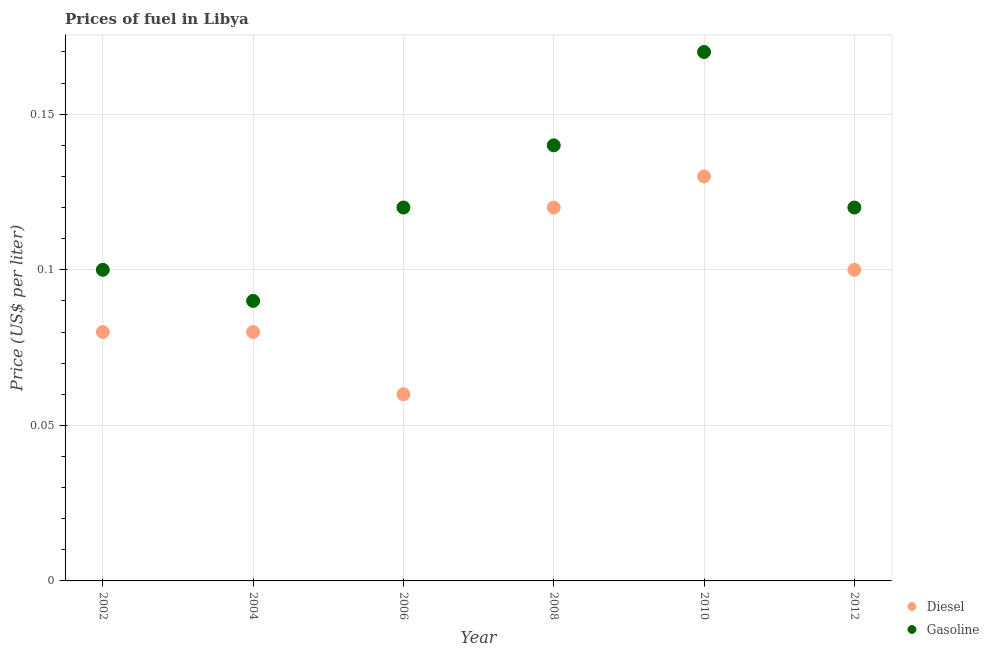Is the number of dotlines equal to the number of legend labels?
Provide a short and direct response. Yes. What is the gasoline price in 2008?
Offer a terse response. 0.14. Across all years, what is the maximum gasoline price?
Make the answer very short. 0.17. Across all years, what is the minimum gasoline price?
Offer a terse response. 0.09. What is the total gasoline price in the graph?
Provide a short and direct response. 0.74. What is the difference between the diesel price in 2008 and that in 2010?
Your answer should be compact. -0.01. What is the difference between the diesel price in 2010 and the gasoline price in 2012?
Keep it short and to the point. 0.01. What is the average gasoline price per year?
Give a very brief answer. 0.12. In the year 2004, what is the difference between the gasoline price and diesel price?
Ensure brevity in your answer.  0.01. In how many years, is the gasoline price greater than 0.12000000000000001 US$ per litre?
Ensure brevity in your answer.  2. What is the ratio of the gasoline price in 2006 to that in 2008?
Offer a very short reply. 0.86. Is the diesel price in 2008 less than that in 2012?
Offer a very short reply. No. What is the difference between the highest and the second highest diesel price?
Your response must be concise. 0.01. What is the difference between the highest and the lowest gasoline price?
Give a very brief answer. 0.08. In how many years, is the gasoline price greater than the average gasoline price taken over all years?
Give a very brief answer. 2. Does the diesel price monotonically increase over the years?
Provide a succinct answer. No. Where does the legend appear in the graph?
Your answer should be very brief. Bottom right. How many legend labels are there?
Offer a very short reply. 2. What is the title of the graph?
Give a very brief answer. Prices of fuel in Libya. What is the label or title of the X-axis?
Provide a short and direct response. Year. What is the label or title of the Y-axis?
Offer a very short reply. Price (US$ per liter). What is the Price (US$ per liter) of Diesel in 2002?
Your answer should be compact. 0.08. What is the Price (US$ per liter) of Gasoline in 2002?
Provide a short and direct response. 0.1. What is the Price (US$ per liter) in Gasoline in 2004?
Keep it short and to the point. 0.09. What is the Price (US$ per liter) of Diesel in 2006?
Your response must be concise. 0.06. What is the Price (US$ per liter) of Gasoline in 2006?
Your answer should be compact. 0.12. What is the Price (US$ per liter) of Diesel in 2008?
Offer a terse response. 0.12. What is the Price (US$ per liter) of Gasoline in 2008?
Keep it short and to the point. 0.14. What is the Price (US$ per liter) of Diesel in 2010?
Your answer should be compact. 0.13. What is the Price (US$ per liter) of Gasoline in 2010?
Your answer should be compact. 0.17. What is the Price (US$ per liter) of Gasoline in 2012?
Make the answer very short. 0.12. Across all years, what is the maximum Price (US$ per liter) of Diesel?
Your answer should be compact. 0.13. Across all years, what is the maximum Price (US$ per liter) in Gasoline?
Your response must be concise. 0.17. Across all years, what is the minimum Price (US$ per liter) in Gasoline?
Your answer should be very brief. 0.09. What is the total Price (US$ per liter) of Diesel in the graph?
Your answer should be very brief. 0.57. What is the total Price (US$ per liter) in Gasoline in the graph?
Make the answer very short. 0.74. What is the difference between the Price (US$ per liter) in Diesel in 2002 and that in 2004?
Offer a very short reply. 0. What is the difference between the Price (US$ per liter) in Gasoline in 2002 and that in 2004?
Ensure brevity in your answer.  0.01. What is the difference between the Price (US$ per liter) in Diesel in 2002 and that in 2006?
Your answer should be very brief. 0.02. What is the difference between the Price (US$ per liter) in Gasoline in 2002 and that in 2006?
Provide a short and direct response. -0.02. What is the difference between the Price (US$ per liter) in Diesel in 2002 and that in 2008?
Offer a terse response. -0.04. What is the difference between the Price (US$ per liter) of Gasoline in 2002 and that in 2008?
Provide a short and direct response. -0.04. What is the difference between the Price (US$ per liter) of Gasoline in 2002 and that in 2010?
Make the answer very short. -0.07. What is the difference between the Price (US$ per liter) of Diesel in 2002 and that in 2012?
Your answer should be very brief. -0.02. What is the difference between the Price (US$ per liter) of Gasoline in 2002 and that in 2012?
Provide a short and direct response. -0.02. What is the difference between the Price (US$ per liter) in Gasoline in 2004 and that in 2006?
Make the answer very short. -0.03. What is the difference between the Price (US$ per liter) of Diesel in 2004 and that in 2008?
Provide a short and direct response. -0.04. What is the difference between the Price (US$ per liter) of Diesel in 2004 and that in 2010?
Give a very brief answer. -0.05. What is the difference between the Price (US$ per liter) in Gasoline in 2004 and that in 2010?
Keep it short and to the point. -0.08. What is the difference between the Price (US$ per liter) in Diesel in 2004 and that in 2012?
Give a very brief answer. -0.02. What is the difference between the Price (US$ per liter) of Gasoline in 2004 and that in 2012?
Make the answer very short. -0.03. What is the difference between the Price (US$ per liter) in Diesel in 2006 and that in 2008?
Offer a very short reply. -0.06. What is the difference between the Price (US$ per liter) of Gasoline in 2006 and that in 2008?
Offer a very short reply. -0.02. What is the difference between the Price (US$ per liter) of Diesel in 2006 and that in 2010?
Keep it short and to the point. -0.07. What is the difference between the Price (US$ per liter) in Diesel in 2006 and that in 2012?
Offer a very short reply. -0.04. What is the difference between the Price (US$ per liter) in Gasoline in 2006 and that in 2012?
Ensure brevity in your answer.  0. What is the difference between the Price (US$ per liter) of Diesel in 2008 and that in 2010?
Ensure brevity in your answer.  -0.01. What is the difference between the Price (US$ per liter) of Gasoline in 2008 and that in 2010?
Your answer should be very brief. -0.03. What is the difference between the Price (US$ per liter) in Gasoline in 2010 and that in 2012?
Ensure brevity in your answer.  0.05. What is the difference between the Price (US$ per liter) of Diesel in 2002 and the Price (US$ per liter) of Gasoline in 2004?
Your response must be concise. -0.01. What is the difference between the Price (US$ per liter) in Diesel in 2002 and the Price (US$ per liter) in Gasoline in 2006?
Keep it short and to the point. -0.04. What is the difference between the Price (US$ per liter) of Diesel in 2002 and the Price (US$ per liter) of Gasoline in 2008?
Your answer should be very brief. -0.06. What is the difference between the Price (US$ per liter) in Diesel in 2002 and the Price (US$ per liter) in Gasoline in 2010?
Provide a short and direct response. -0.09. What is the difference between the Price (US$ per liter) of Diesel in 2002 and the Price (US$ per liter) of Gasoline in 2012?
Offer a very short reply. -0.04. What is the difference between the Price (US$ per liter) of Diesel in 2004 and the Price (US$ per liter) of Gasoline in 2006?
Your response must be concise. -0.04. What is the difference between the Price (US$ per liter) of Diesel in 2004 and the Price (US$ per liter) of Gasoline in 2008?
Your answer should be compact. -0.06. What is the difference between the Price (US$ per liter) of Diesel in 2004 and the Price (US$ per liter) of Gasoline in 2010?
Provide a short and direct response. -0.09. What is the difference between the Price (US$ per liter) in Diesel in 2004 and the Price (US$ per liter) in Gasoline in 2012?
Keep it short and to the point. -0.04. What is the difference between the Price (US$ per liter) of Diesel in 2006 and the Price (US$ per liter) of Gasoline in 2008?
Provide a succinct answer. -0.08. What is the difference between the Price (US$ per liter) in Diesel in 2006 and the Price (US$ per liter) in Gasoline in 2010?
Offer a terse response. -0.11. What is the difference between the Price (US$ per liter) of Diesel in 2006 and the Price (US$ per liter) of Gasoline in 2012?
Offer a terse response. -0.06. What is the difference between the Price (US$ per liter) in Diesel in 2008 and the Price (US$ per liter) in Gasoline in 2012?
Provide a short and direct response. 0. What is the difference between the Price (US$ per liter) in Diesel in 2010 and the Price (US$ per liter) in Gasoline in 2012?
Keep it short and to the point. 0.01. What is the average Price (US$ per liter) of Diesel per year?
Your answer should be compact. 0.1. What is the average Price (US$ per liter) of Gasoline per year?
Keep it short and to the point. 0.12. In the year 2002, what is the difference between the Price (US$ per liter) of Diesel and Price (US$ per liter) of Gasoline?
Provide a short and direct response. -0.02. In the year 2004, what is the difference between the Price (US$ per liter) in Diesel and Price (US$ per liter) in Gasoline?
Ensure brevity in your answer.  -0.01. In the year 2006, what is the difference between the Price (US$ per liter) in Diesel and Price (US$ per liter) in Gasoline?
Provide a short and direct response. -0.06. In the year 2008, what is the difference between the Price (US$ per liter) in Diesel and Price (US$ per liter) in Gasoline?
Offer a terse response. -0.02. In the year 2010, what is the difference between the Price (US$ per liter) in Diesel and Price (US$ per liter) in Gasoline?
Your response must be concise. -0.04. In the year 2012, what is the difference between the Price (US$ per liter) in Diesel and Price (US$ per liter) in Gasoline?
Give a very brief answer. -0.02. What is the ratio of the Price (US$ per liter) of Diesel in 2002 to that in 2004?
Offer a terse response. 1. What is the ratio of the Price (US$ per liter) of Diesel in 2002 to that in 2006?
Your answer should be very brief. 1.33. What is the ratio of the Price (US$ per liter) in Gasoline in 2002 to that in 2008?
Provide a short and direct response. 0.71. What is the ratio of the Price (US$ per liter) in Diesel in 2002 to that in 2010?
Your answer should be compact. 0.62. What is the ratio of the Price (US$ per liter) in Gasoline in 2002 to that in 2010?
Your answer should be very brief. 0.59. What is the ratio of the Price (US$ per liter) in Diesel in 2002 to that in 2012?
Ensure brevity in your answer.  0.8. What is the ratio of the Price (US$ per liter) in Gasoline in 2004 to that in 2006?
Give a very brief answer. 0.75. What is the ratio of the Price (US$ per liter) of Diesel in 2004 to that in 2008?
Your answer should be compact. 0.67. What is the ratio of the Price (US$ per liter) in Gasoline in 2004 to that in 2008?
Offer a very short reply. 0.64. What is the ratio of the Price (US$ per liter) of Diesel in 2004 to that in 2010?
Keep it short and to the point. 0.62. What is the ratio of the Price (US$ per liter) in Gasoline in 2004 to that in 2010?
Ensure brevity in your answer.  0.53. What is the ratio of the Price (US$ per liter) in Diesel in 2006 to that in 2008?
Offer a terse response. 0.5. What is the ratio of the Price (US$ per liter) of Gasoline in 2006 to that in 2008?
Your answer should be compact. 0.86. What is the ratio of the Price (US$ per liter) in Diesel in 2006 to that in 2010?
Provide a succinct answer. 0.46. What is the ratio of the Price (US$ per liter) in Gasoline in 2006 to that in 2010?
Keep it short and to the point. 0.71. What is the ratio of the Price (US$ per liter) of Gasoline in 2006 to that in 2012?
Give a very brief answer. 1. What is the ratio of the Price (US$ per liter) in Diesel in 2008 to that in 2010?
Offer a very short reply. 0.92. What is the ratio of the Price (US$ per liter) in Gasoline in 2008 to that in 2010?
Your answer should be very brief. 0.82. What is the ratio of the Price (US$ per liter) of Diesel in 2008 to that in 2012?
Make the answer very short. 1.2. What is the ratio of the Price (US$ per liter) in Gasoline in 2010 to that in 2012?
Keep it short and to the point. 1.42. What is the difference between the highest and the second highest Price (US$ per liter) of Gasoline?
Offer a terse response. 0.03. What is the difference between the highest and the lowest Price (US$ per liter) in Diesel?
Offer a terse response. 0.07. 